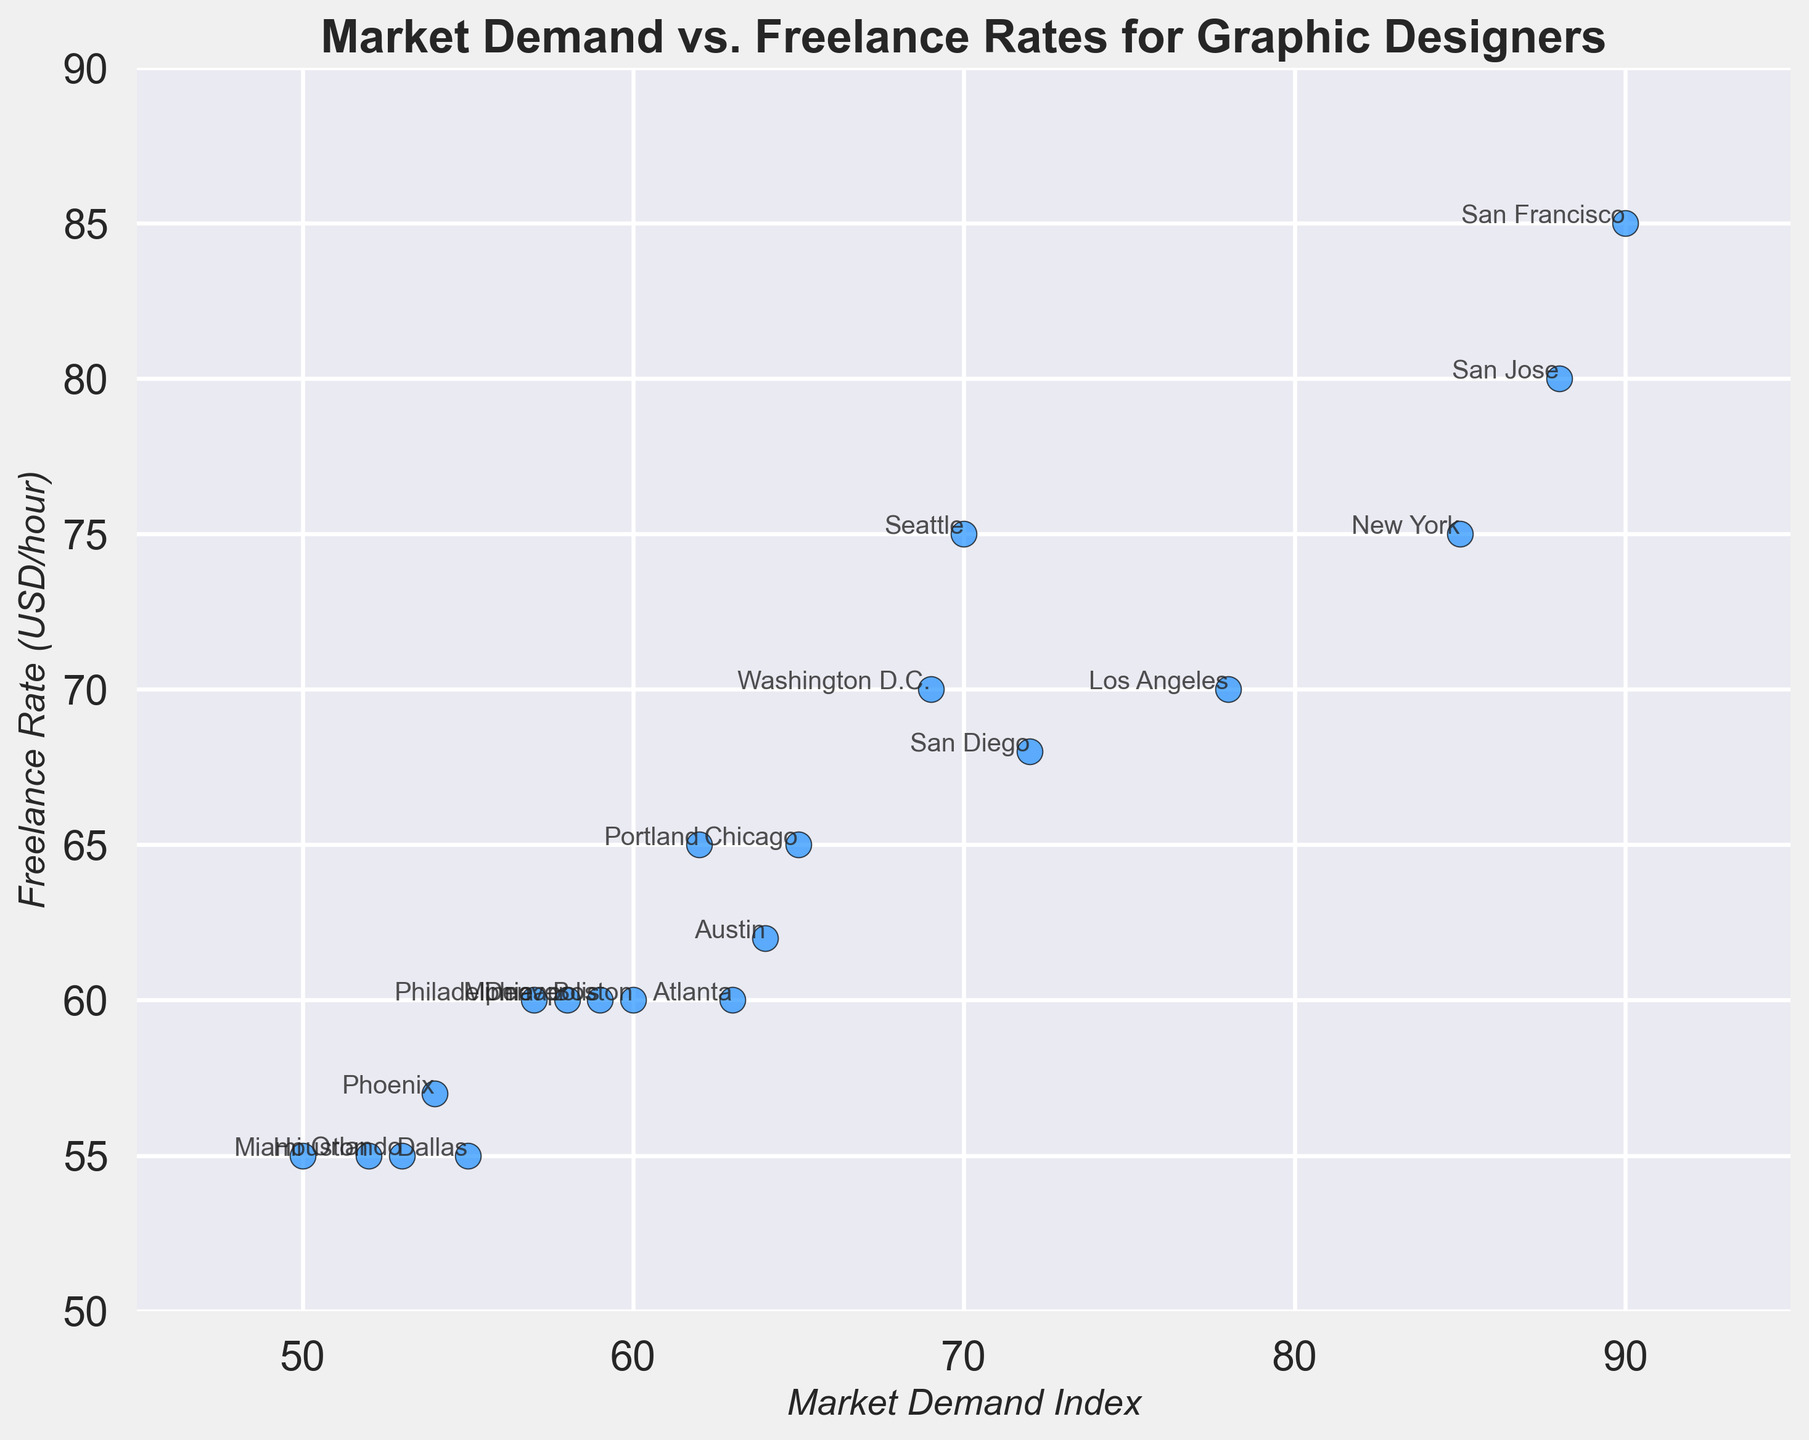What is the city with the highest Freelance Rate? The highest point on the Y-axis indicates the city with the highest Freelance Rate. San Francisco is at the top of the Y-axis with a rate of 85 USD/hour.
Answer: San Francisco Which city has the lowest Market Demand Index? The lowest point on the X-axis indicates the city with the lowest Market Demand Index. Miami has the lowest Market Demand Index of 50.
Answer: Miami Which city has a Freelance Rate of 75 USD/hour and what is its Market Demand Index? Look for the point on the Y-axis that corresponds to 75 USD/hour. New York and Seattle both have a Freelance Rate of 75 USD/hour. New York has a Market Demand Index of 85, and Seattle has 70.
Answer: New York: 85, Seattle: 70 What is the average Freelance Rate for the cities with a Market Demand Index above 80? Identify cities with a Market Demand Index above 80: New York (75), San Francisco (85), and San Jose (80). Calculate the average Freelance Rate: (75 + 85 + 80) / 3 = 80 USD/hour.
Answer: 80 USD/hour What is the difference in Freelance Rate between the city with the highest Market Demand Index and the city with the lowest Market Demand Index? The city with the highest Market Demand Index is San Francisco (90, 85 USD/hour), and the lowest is Miami (50, 55 USD/hour). The difference in Freelance Rate is 85 - 55.
Answer: 30 USD/hour Which cities have a Freelance Rate exactly at 60 USD/hour? Look for points that intersect the Y-axis at 60. Boston, Denver, Atlanta, Philadelphia, and Minneapolis all have a Freelance Rate of 60 USD/hour.
Answer: Boston, Denver, Atlanta, Philadelphia, Minneapolis Compare the Freelance Rates of New York and Los Angeles. Which city has the higher rate and by how much? New York has a Freelance Rate of 75 USD/hour while Los Angeles has 70 USD/hour. The rate for New York is higher by 75 - 70 = 5 USD/hour.
Answer: New York by 5 USD/hour How many cities have a Freelance Rate less than or equal to 65 USD/hour? Identify points at or below 65 on the Y-axis: Chicago, Dallas, Boston, Austin, Denver, Philadelphia, Atlanta, Phoenix, Portland, Minneapolis, Houston, Miami, and Orlando. There are 13 cities in total.
Answer: 13 cities 